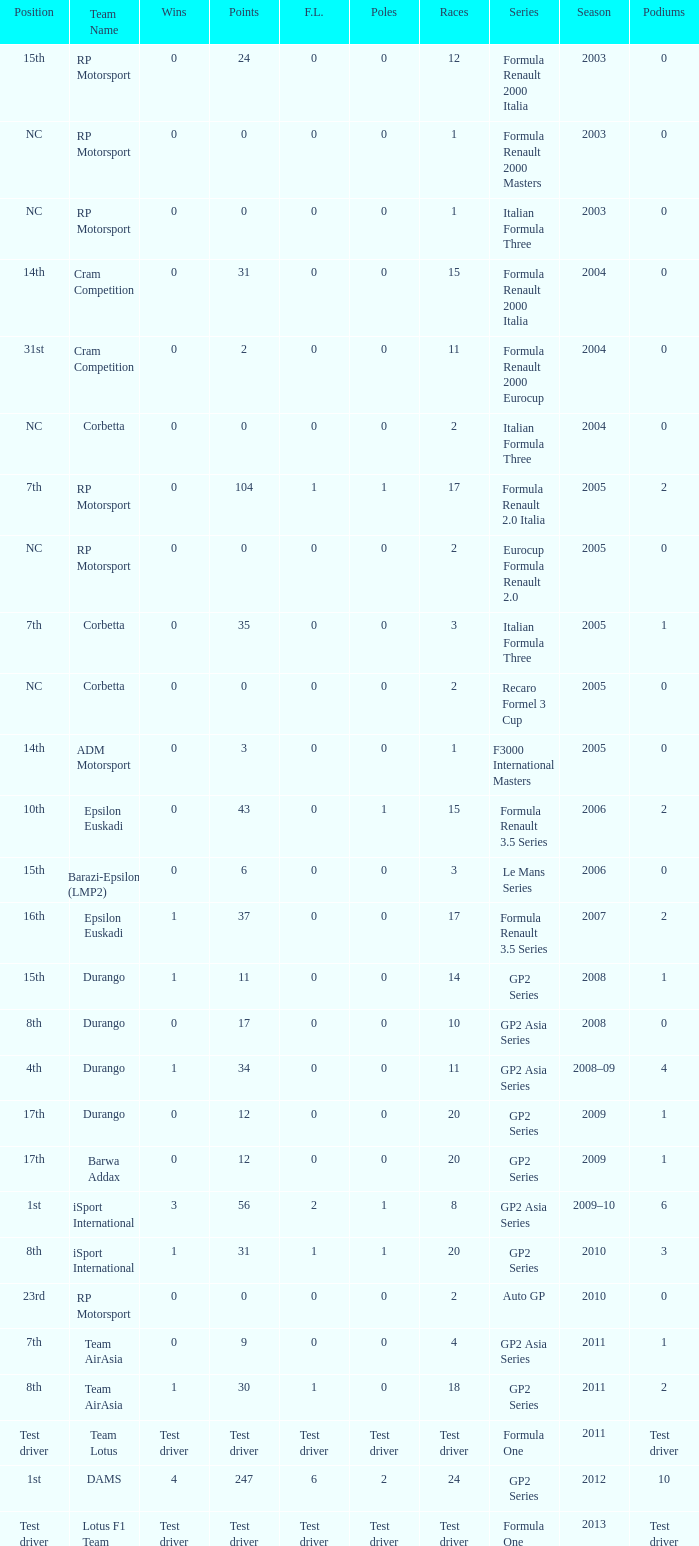What is the number of poles with 104 points? 1.0. 